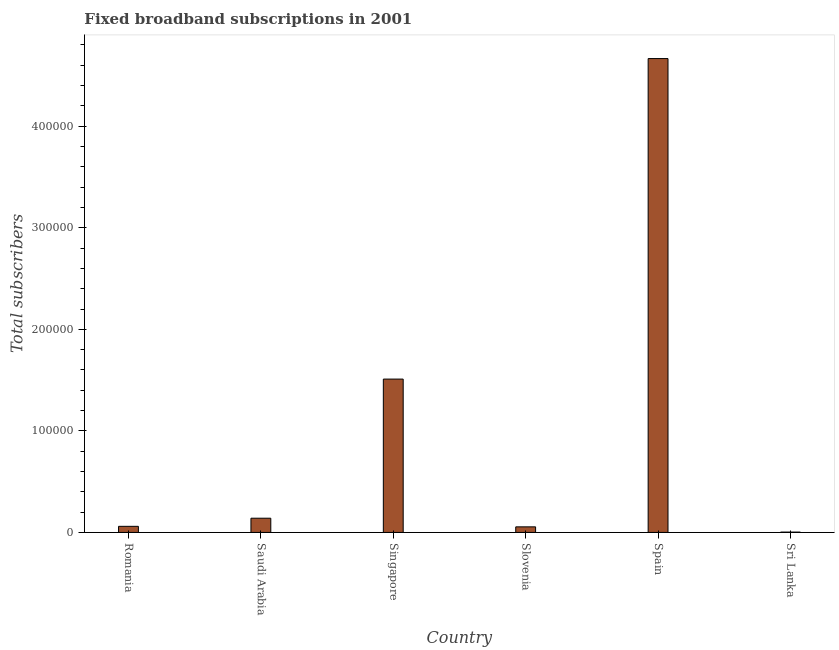Does the graph contain grids?
Provide a short and direct response. No. What is the title of the graph?
Provide a succinct answer. Fixed broadband subscriptions in 2001. What is the label or title of the X-axis?
Make the answer very short. Country. What is the label or title of the Y-axis?
Provide a succinct answer. Total subscribers. What is the total number of fixed broadband subscriptions in Sri Lanka?
Make the answer very short. 327. Across all countries, what is the maximum total number of fixed broadband subscriptions?
Your answer should be very brief. 4.67e+05. Across all countries, what is the minimum total number of fixed broadband subscriptions?
Give a very brief answer. 327. In which country was the total number of fixed broadband subscriptions maximum?
Provide a succinct answer. Spain. In which country was the total number of fixed broadband subscriptions minimum?
Make the answer very short. Sri Lanka. What is the sum of the total number of fixed broadband subscriptions?
Keep it short and to the point. 6.43e+05. What is the difference between the total number of fixed broadband subscriptions in Slovenia and Sri Lanka?
Your response must be concise. 5173. What is the average total number of fixed broadband subscriptions per country?
Your answer should be compact. 1.07e+05. What is the median total number of fixed broadband subscriptions?
Give a very brief answer. 10000. What is the ratio of the total number of fixed broadband subscriptions in Saudi Arabia to that in Sri Lanka?
Your response must be concise. 42.81. Is the total number of fixed broadband subscriptions in Romania less than that in Slovenia?
Give a very brief answer. No. What is the difference between the highest and the second highest total number of fixed broadband subscriptions?
Offer a very short reply. 3.16e+05. Is the sum of the total number of fixed broadband subscriptions in Romania and Slovenia greater than the maximum total number of fixed broadband subscriptions across all countries?
Offer a terse response. No. What is the difference between the highest and the lowest total number of fixed broadband subscriptions?
Ensure brevity in your answer.  4.66e+05. In how many countries, is the total number of fixed broadband subscriptions greater than the average total number of fixed broadband subscriptions taken over all countries?
Make the answer very short. 2. Are all the bars in the graph horizontal?
Ensure brevity in your answer.  No. How many countries are there in the graph?
Keep it short and to the point. 6. What is the difference between two consecutive major ticks on the Y-axis?
Make the answer very short. 1.00e+05. What is the Total subscribers in Romania?
Ensure brevity in your answer.  6000. What is the Total subscribers of Saudi Arabia?
Offer a very short reply. 1.40e+04. What is the Total subscribers of Singapore?
Your answer should be compact. 1.51e+05. What is the Total subscribers of Slovenia?
Give a very brief answer. 5500. What is the Total subscribers in Spain?
Your answer should be compact. 4.67e+05. What is the Total subscribers in Sri Lanka?
Provide a short and direct response. 327. What is the difference between the Total subscribers in Romania and Saudi Arabia?
Your answer should be compact. -8000. What is the difference between the Total subscribers in Romania and Singapore?
Ensure brevity in your answer.  -1.45e+05. What is the difference between the Total subscribers in Romania and Slovenia?
Your answer should be very brief. 500. What is the difference between the Total subscribers in Romania and Spain?
Give a very brief answer. -4.61e+05. What is the difference between the Total subscribers in Romania and Sri Lanka?
Ensure brevity in your answer.  5673. What is the difference between the Total subscribers in Saudi Arabia and Singapore?
Ensure brevity in your answer.  -1.37e+05. What is the difference between the Total subscribers in Saudi Arabia and Slovenia?
Offer a very short reply. 8500. What is the difference between the Total subscribers in Saudi Arabia and Spain?
Make the answer very short. -4.53e+05. What is the difference between the Total subscribers in Saudi Arabia and Sri Lanka?
Your response must be concise. 1.37e+04. What is the difference between the Total subscribers in Singapore and Slovenia?
Your answer should be compact. 1.46e+05. What is the difference between the Total subscribers in Singapore and Spain?
Make the answer very short. -3.16e+05. What is the difference between the Total subscribers in Singapore and Sri Lanka?
Your answer should be compact. 1.51e+05. What is the difference between the Total subscribers in Slovenia and Spain?
Give a very brief answer. -4.61e+05. What is the difference between the Total subscribers in Slovenia and Sri Lanka?
Your answer should be very brief. 5173. What is the difference between the Total subscribers in Spain and Sri Lanka?
Offer a terse response. 4.66e+05. What is the ratio of the Total subscribers in Romania to that in Saudi Arabia?
Ensure brevity in your answer.  0.43. What is the ratio of the Total subscribers in Romania to that in Slovenia?
Make the answer very short. 1.09. What is the ratio of the Total subscribers in Romania to that in Spain?
Your response must be concise. 0.01. What is the ratio of the Total subscribers in Romania to that in Sri Lanka?
Ensure brevity in your answer.  18.35. What is the ratio of the Total subscribers in Saudi Arabia to that in Singapore?
Offer a terse response. 0.09. What is the ratio of the Total subscribers in Saudi Arabia to that in Slovenia?
Ensure brevity in your answer.  2.54. What is the ratio of the Total subscribers in Saudi Arabia to that in Spain?
Your answer should be very brief. 0.03. What is the ratio of the Total subscribers in Saudi Arabia to that in Sri Lanka?
Give a very brief answer. 42.81. What is the ratio of the Total subscribers in Singapore to that in Slovenia?
Offer a very short reply. 27.45. What is the ratio of the Total subscribers in Singapore to that in Spain?
Provide a succinct answer. 0.32. What is the ratio of the Total subscribers in Singapore to that in Sri Lanka?
Keep it short and to the point. 461.77. What is the ratio of the Total subscribers in Slovenia to that in Spain?
Your response must be concise. 0.01. What is the ratio of the Total subscribers in Slovenia to that in Sri Lanka?
Provide a short and direct response. 16.82. What is the ratio of the Total subscribers in Spain to that in Sri Lanka?
Your answer should be compact. 1426.91. 